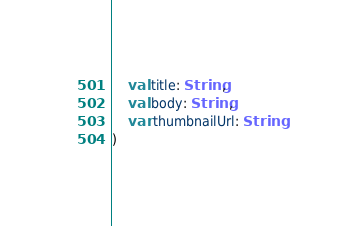Convert code to text. <code><loc_0><loc_0><loc_500><loc_500><_Kotlin_>    val title: String,
    val body: String,
    var thumbnailUrl: String
)</code> 